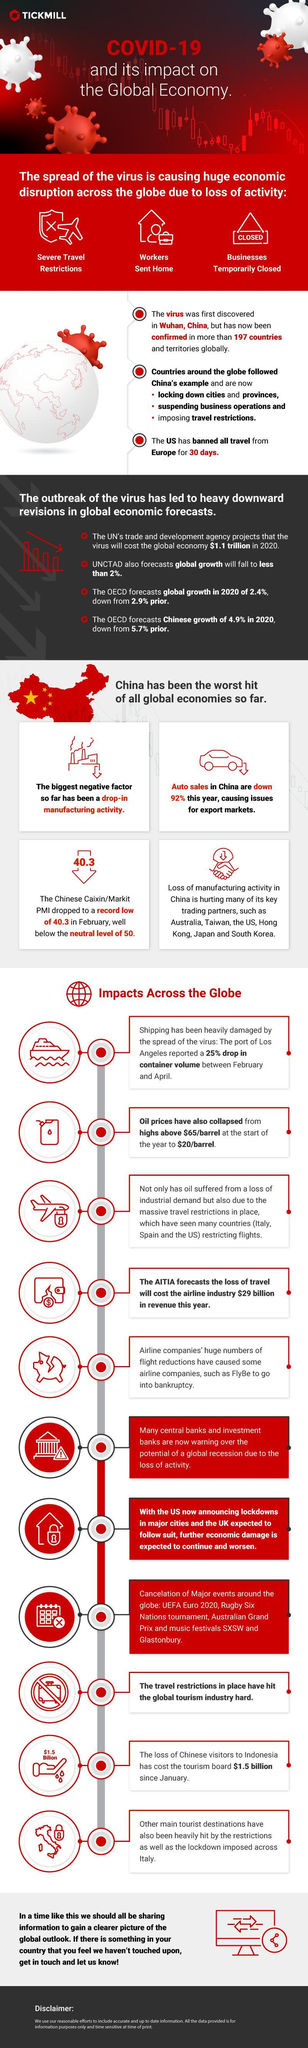By how much has the Chinese Caixin/Markit PMI dropped from its neutral level
Answer the question with a short phrase. 9.7 by how much dollars has the oil price per barrel reduced 45 In how many months did the container volume drop by 25% 3 